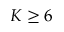Convert formula to latex. <formula><loc_0><loc_0><loc_500><loc_500>K \geq 6</formula> 